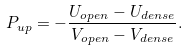<formula> <loc_0><loc_0><loc_500><loc_500>P _ { u p } = - \frac { U _ { o p e n } - U _ { d e n s e } } { V _ { o p e n } - V _ { d e n s e } } .</formula> 